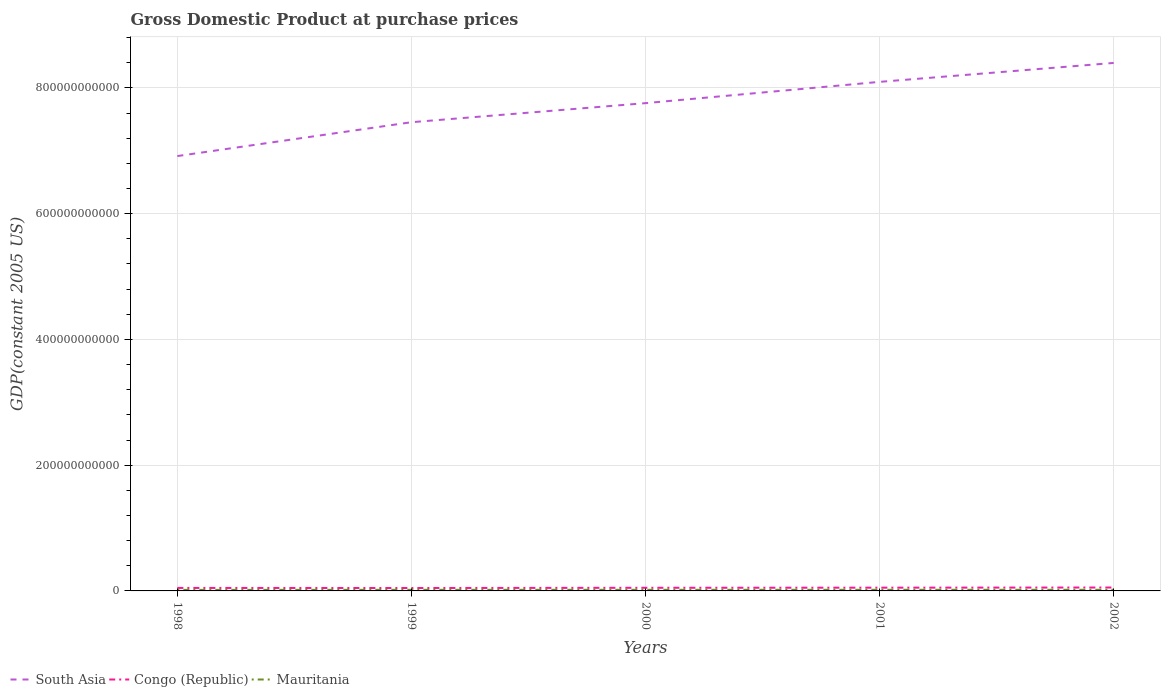Does the line corresponding to Congo (Republic) intersect with the line corresponding to South Asia?
Provide a short and direct response. No. Is the number of lines equal to the number of legend labels?
Your response must be concise. Yes. Across all years, what is the maximum GDP at purchase prices in Mauritania?
Offer a terse response. 1.62e+09. In which year was the GDP at purchase prices in Mauritania maximum?
Your response must be concise. 1998. What is the total GDP at purchase prices in Congo (Republic) in the graph?
Keep it short and to the point. -3.51e+08. What is the difference between the highest and the second highest GDP at purchase prices in Congo (Republic)?
Give a very brief answer. 7.78e+08. What is the difference between two consecutive major ticks on the Y-axis?
Make the answer very short. 2.00e+11. Are the values on the major ticks of Y-axis written in scientific E-notation?
Make the answer very short. No. What is the title of the graph?
Offer a very short reply. Gross Domestic Product at purchase prices. What is the label or title of the X-axis?
Ensure brevity in your answer.  Years. What is the label or title of the Y-axis?
Your answer should be compact. GDP(constant 2005 US). What is the GDP(constant 2005 US) in South Asia in 1998?
Offer a very short reply. 6.92e+11. What is the GDP(constant 2005 US) of Congo (Republic) in 1998?
Give a very brief answer. 4.76e+09. What is the GDP(constant 2005 US) in Mauritania in 1998?
Offer a very short reply. 1.62e+09. What is the GDP(constant 2005 US) of South Asia in 1999?
Offer a terse response. 7.46e+11. What is the GDP(constant 2005 US) of Congo (Republic) in 1999?
Provide a succinct answer. 4.64e+09. What is the GDP(constant 2005 US) in Mauritania in 1999?
Make the answer very short. 1.75e+09. What is the GDP(constant 2005 US) of South Asia in 2000?
Offer a terse response. 7.76e+11. What is the GDP(constant 2005 US) in Congo (Republic) in 2000?
Keep it short and to the point. 4.99e+09. What is the GDP(constant 2005 US) in Mauritania in 2000?
Ensure brevity in your answer.  1.74e+09. What is the GDP(constant 2005 US) of South Asia in 2001?
Your answer should be very brief. 8.10e+11. What is the GDP(constant 2005 US) of Congo (Republic) in 2001?
Ensure brevity in your answer.  5.18e+09. What is the GDP(constant 2005 US) in Mauritania in 2001?
Offer a terse response. 1.78e+09. What is the GDP(constant 2005 US) in South Asia in 2002?
Provide a succinct answer. 8.40e+11. What is the GDP(constant 2005 US) of Congo (Republic) in 2002?
Give a very brief answer. 5.42e+09. What is the GDP(constant 2005 US) in Mauritania in 2002?
Your answer should be very brief. 1.79e+09. Across all years, what is the maximum GDP(constant 2005 US) in South Asia?
Your response must be concise. 8.40e+11. Across all years, what is the maximum GDP(constant 2005 US) in Congo (Republic)?
Provide a succinct answer. 5.42e+09. Across all years, what is the maximum GDP(constant 2005 US) of Mauritania?
Your answer should be compact. 1.79e+09. Across all years, what is the minimum GDP(constant 2005 US) in South Asia?
Provide a short and direct response. 6.92e+11. Across all years, what is the minimum GDP(constant 2005 US) in Congo (Republic)?
Make the answer very short. 4.64e+09. Across all years, what is the minimum GDP(constant 2005 US) in Mauritania?
Make the answer very short. 1.62e+09. What is the total GDP(constant 2005 US) in South Asia in the graph?
Provide a succinct answer. 3.86e+12. What is the total GDP(constant 2005 US) of Congo (Republic) in the graph?
Ensure brevity in your answer.  2.50e+1. What is the total GDP(constant 2005 US) in Mauritania in the graph?
Offer a terse response. 8.68e+09. What is the difference between the GDP(constant 2005 US) in South Asia in 1998 and that in 1999?
Make the answer very short. -5.39e+1. What is the difference between the GDP(constant 2005 US) of Congo (Republic) in 1998 and that in 1999?
Provide a short and direct response. 1.23e+08. What is the difference between the GDP(constant 2005 US) in Mauritania in 1998 and that in 1999?
Give a very brief answer. -1.25e+08. What is the difference between the GDP(constant 2005 US) in South Asia in 1998 and that in 2000?
Provide a succinct answer. -8.42e+1. What is the difference between the GDP(constant 2005 US) in Congo (Republic) in 1998 and that in 2000?
Your answer should be compact. -2.28e+08. What is the difference between the GDP(constant 2005 US) of Mauritania in 1998 and that in 2000?
Offer a terse response. -1.18e+08. What is the difference between the GDP(constant 2005 US) in South Asia in 1998 and that in 2001?
Your response must be concise. -1.18e+11. What is the difference between the GDP(constant 2005 US) in Congo (Republic) in 1998 and that in 2001?
Ensure brevity in your answer.  -4.18e+08. What is the difference between the GDP(constant 2005 US) in Mauritania in 1998 and that in 2001?
Provide a short and direct response. -1.53e+08. What is the difference between the GDP(constant 2005 US) of South Asia in 1998 and that in 2002?
Provide a succinct answer. -1.48e+11. What is the difference between the GDP(constant 2005 US) in Congo (Republic) in 1998 and that in 2002?
Your answer should be very brief. -6.55e+08. What is the difference between the GDP(constant 2005 US) of Mauritania in 1998 and that in 2002?
Make the answer very short. -1.65e+08. What is the difference between the GDP(constant 2005 US) of South Asia in 1999 and that in 2000?
Provide a succinct answer. -3.03e+1. What is the difference between the GDP(constant 2005 US) of Congo (Republic) in 1999 and that in 2000?
Offer a very short reply. -3.51e+08. What is the difference between the GDP(constant 2005 US) in Mauritania in 1999 and that in 2000?
Offer a very short reply. 7.53e+06. What is the difference between the GDP(constant 2005 US) of South Asia in 1999 and that in 2001?
Your answer should be very brief. -6.42e+1. What is the difference between the GDP(constant 2005 US) in Congo (Republic) in 1999 and that in 2001?
Keep it short and to the point. -5.41e+08. What is the difference between the GDP(constant 2005 US) in Mauritania in 1999 and that in 2001?
Provide a succinct answer. -2.75e+07. What is the difference between the GDP(constant 2005 US) in South Asia in 1999 and that in 2002?
Your response must be concise. -9.43e+1. What is the difference between the GDP(constant 2005 US) of Congo (Republic) in 1999 and that in 2002?
Provide a succinct answer. -7.78e+08. What is the difference between the GDP(constant 2005 US) in Mauritania in 1999 and that in 2002?
Offer a very short reply. -3.93e+07. What is the difference between the GDP(constant 2005 US) in South Asia in 2000 and that in 2001?
Offer a terse response. -3.38e+1. What is the difference between the GDP(constant 2005 US) in Congo (Republic) in 2000 and that in 2001?
Ensure brevity in your answer.  -1.90e+08. What is the difference between the GDP(constant 2005 US) of Mauritania in 2000 and that in 2001?
Your response must be concise. -3.50e+07. What is the difference between the GDP(constant 2005 US) in South Asia in 2000 and that in 2002?
Make the answer very short. -6.40e+1. What is the difference between the GDP(constant 2005 US) of Congo (Republic) in 2000 and that in 2002?
Make the answer very short. -4.27e+08. What is the difference between the GDP(constant 2005 US) of Mauritania in 2000 and that in 2002?
Give a very brief answer. -4.68e+07. What is the difference between the GDP(constant 2005 US) of South Asia in 2001 and that in 2002?
Your response must be concise. -3.01e+1. What is the difference between the GDP(constant 2005 US) of Congo (Republic) in 2001 and that in 2002?
Provide a short and direct response. -2.37e+08. What is the difference between the GDP(constant 2005 US) of Mauritania in 2001 and that in 2002?
Ensure brevity in your answer.  -1.18e+07. What is the difference between the GDP(constant 2005 US) in South Asia in 1998 and the GDP(constant 2005 US) in Congo (Republic) in 1999?
Your answer should be compact. 6.87e+11. What is the difference between the GDP(constant 2005 US) of South Asia in 1998 and the GDP(constant 2005 US) of Mauritania in 1999?
Your response must be concise. 6.90e+11. What is the difference between the GDP(constant 2005 US) in Congo (Republic) in 1998 and the GDP(constant 2005 US) in Mauritania in 1999?
Your answer should be very brief. 3.01e+09. What is the difference between the GDP(constant 2005 US) of South Asia in 1998 and the GDP(constant 2005 US) of Congo (Republic) in 2000?
Your answer should be compact. 6.87e+11. What is the difference between the GDP(constant 2005 US) of South Asia in 1998 and the GDP(constant 2005 US) of Mauritania in 2000?
Keep it short and to the point. 6.90e+11. What is the difference between the GDP(constant 2005 US) of Congo (Republic) in 1998 and the GDP(constant 2005 US) of Mauritania in 2000?
Provide a short and direct response. 3.02e+09. What is the difference between the GDP(constant 2005 US) of South Asia in 1998 and the GDP(constant 2005 US) of Congo (Republic) in 2001?
Ensure brevity in your answer.  6.86e+11. What is the difference between the GDP(constant 2005 US) in South Asia in 1998 and the GDP(constant 2005 US) in Mauritania in 2001?
Make the answer very short. 6.90e+11. What is the difference between the GDP(constant 2005 US) of Congo (Republic) in 1998 and the GDP(constant 2005 US) of Mauritania in 2001?
Give a very brief answer. 2.98e+09. What is the difference between the GDP(constant 2005 US) of South Asia in 1998 and the GDP(constant 2005 US) of Congo (Republic) in 2002?
Keep it short and to the point. 6.86e+11. What is the difference between the GDP(constant 2005 US) of South Asia in 1998 and the GDP(constant 2005 US) of Mauritania in 2002?
Keep it short and to the point. 6.90e+11. What is the difference between the GDP(constant 2005 US) of Congo (Republic) in 1998 and the GDP(constant 2005 US) of Mauritania in 2002?
Your answer should be compact. 2.97e+09. What is the difference between the GDP(constant 2005 US) in South Asia in 1999 and the GDP(constant 2005 US) in Congo (Republic) in 2000?
Give a very brief answer. 7.41e+11. What is the difference between the GDP(constant 2005 US) of South Asia in 1999 and the GDP(constant 2005 US) of Mauritania in 2000?
Your answer should be very brief. 7.44e+11. What is the difference between the GDP(constant 2005 US) of Congo (Republic) in 1999 and the GDP(constant 2005 US) of Mauritania in 2000?
Provide a succinct answer. 2.89e+09. What is the difference between the GDP(constant 2005 US) in South Asia in 1999 and the GDP(constant 2005 US) in Congo (Republic) in 2001?
Keep it short and to the point. 7.40e+11. What is the difference between the GDP(constant 2005 US) of South Asia in 1999 and the GDP(constant 2005 US) of Mauritania in 2001?
Make the answer very short. 7.44e+11. What is the difference between the GDP(constant 2005 US) in Congo (Republic) in 1999 and the GDP(constant 2005 US) in Mauritania in 2001?
Your answer should be compact. 2.86e+09. What is the difference between the GDP(constant 2005 US) in South Asia in 1999 and the GDP(constant 2005 US) in Congo (Republic) in 2002?
Your answer should be compact. 7.40e+11. What is the difference between the GDP(constant 2005 US) in South Asia in 1999 and the GDP(constant 2005 US) in Mauritania in 2002?
Your answer should be very brief. 7.44e+11. What is the difference between the GDP(constant 2005 US) of Congo (Republic) in 1999 and the GDP(constant 2005 US) of Mauritania in 2002?
Your response must be concise. 2.85e+09. What is the difference between the GDP(constant 2005 US) in South Asia in 2000 and the GDP(constant 2005 US) in Congo (Republic) in 2001?
Give a very brief answer. 7.71e+11. What is the difference between the GDP(constant 2005 US) in South Asia in 2000 and the GDP(constant 2005 US) in Mauritania in 2001?
Give a very brief answer. 7.74e+11. What is the difference between the GDP(constant 2005 US) of Congo (Republic) in 2000 and the GDP(constant 2005 US) of Mauritania in 2001?
Your answer should be compact. 3.21e+09. What is the difference between the GDP(constant 2005 US) in South Asia in 2000 and the GDP(constant 2005 US) in Congo (Republic) in 2002?
Ensure brevity in your answer.  7.70e+11. What is the difference between the GDP(constant 2005 US) of South Asia in 2000 and the GDP(constant 2005 US) of Mauritania in 2002?
Keep it short and to the point. 7.74e+11. What is the difference between the GDP(constant 2005 US) in Congo (Republic) in 2000 and the GDP(constant 2005 US) in Mauritania in 2002?
Give a very brief answer. 3.20e+09. What is the difference between the GDP(constant 2005 US) of South Asia in 2001 and the GDP(constant 2005 US) of Congo (Republic) in 2002?
Keep it short and to the point. 8.04e+11. What is the difference between the GDP(constant 2005 US) of South Asia in 2001 and the GDP(constant 2005 US) of Mauritania in 2002?
Provide a succinct answer. 8.08e+11. What is the difference between the GDP(constant 2005 US) in Congo (Republic) in 2001 and the GDP(constant 2005 US) in Mauritania in 2002?
Make the answer very short. 3.39e+09. What is the average GDP(constant 2005 US) of South Asia per year?
Offer a terse response. 7.72e+11. What is the average GDP(constant 2005 US) in Congo (Republic) per year?
Provide a succinct answer. 5.00e+09. What is the average GDP(constant 2005 US) of Mauritania per year?
Keep it short and to the point. 1.74e+09. In the year 1998, what is the difference between the GDP(constant 2005 US) of South Asia and GDP(constant 2005 US) of Congo (Republic)?
Give a very brief answer. 6.87e+11. In the year 1998, what is the difference between the GDP(constant 2005 US) of South Asia and GDP(constant 2005 US) of Mauritania?
Provide a short and direct response. 6.90e+11. In the year 1998, what is the difference between the GDP(constant 2005 US) of Congo (Republic) and GDP(constant 2005 US) of Mauritania?
Make the answer very short. 3.14e+09. In the year 1999, what is the difference between the GDP(constant 2005 US) in South Asia and GDP(constant 2005 US) in Congo (Republic)?
Offer a terse response. 7.41e+11. In the year 1999, what is the difference between the GDP(constant 2005 US) in South Asia and GDP(constant 2005 US) in Mauritania?
Offer a terse response. 7.44e+11. In the year 1999, what is the difference between the GDP(constant 2005 US) of Congo (Republic) and GDP(constant 2005 US) of Mauritania?
Offer a very short reply. 2.89e+09. In the year 2000, what is the difference between the GDP(constant 2005 US) in South Asia and GDP(constant 2005 US) in Congo (Republic)?
Your response must be concise. 7.71e+11. In the year 2000, what is the difference between the GDP(constant 2005 US) in South Asia and GDP(constant 2005 US) in Mauritania?
Make the answer very short. 7.74e+11. In the year 2000, what is the difference between the GDP(constant 2005 US) of Congo (Republic) and GDP(constant 2005 US) of Mauritania?
Provide a short and direct response. 3.25e+09. In the year 2001, what is the difference between the GDP(constant 2005 US) in South Asia and GDP(constant 2005 US) in Congo (Republic)?
Provide a succinct answer. 8.04e+11. In the year 2001, what is the difference between the GDP(constant 2005 US) in South Asia and GDP(constant 2005 US) in Mauritania?
Provide a short and direct response. 8.08e+11. In the year 2001, what is the difference between the GDP(constant 2005 US) of Congo (Republic) and GDP(constant 2005 US) of Mauritania?
Ensure brevity in your answer.  3.40e+09. In the year 2002, what is the difference between the GDP(constant 2005 US) in South Asia and GDP(constant 2005 US) in Congo (Republic)?
Ensure brevity in your answer.  8.34e+11. In the year 2002, what is the difference between the GDP(constant 2005 US) in South Asia and GDP(constant 2005 US) in Mauritania?
Offer a terse response. 8.38e+11. In the year 2002, what is the difference between the GDP(constant 2005 US) in Congo (Republic) and GDP(constant 2005 US) in Mauritania?
Ensure brevity in your answer.  3.63e+09. What is the ratio of the GDP(constant 2005 US) of South Asia in 1998 to that in 1999?
Give a very brief answer. 0.93. What is the ratio of the GDP(constant 2005 US) of Congo (Republic) in 1998 to that in 1999?
Give a very brief answer. 1.03. What is the ratio of the GDP(constant 2005 US) of Mauritania in 1998 to that in 1999?
Your answer should be very brief. 0.93. What is the ratio of the GDP(constant 2005 US) in South Asia in 1998 to that in 2000?
Ensure brevity in your answer.  0.89. What is the ratio of the GDP(constant 2005 US) in Congo (Republic) in 1998 to that in 2000?
Provide a short and direct response. 0.95. What is the ratio of the GDP(constant 2005 US) of Mauritania in 1998 to that in 2000?
Make the answer very short. 0.93. What is the ratio of the GDP(constant 2005 US) in South Asia in 1998 to that in 2001?
Provide a short and direct response. 0.85. What is the ratio of the GDP(constant 2005 US) in Congo (Republic) in 1998 to that in 2001?
Provide a succinct answer. 0.92. What is the ratio of the GDP(constant 2005 US) in Mauritania in 1998 to that in 2001?
Your response must be concise. 0.91. What is the ratio of the GDP(constant 2005 US) of South Asia in 1998 to that in 2002?
Your answer should be compact. 0.82. What is the ratio of the GDP(constant 2005 US) of Congo (Republic) in 1998 to that in 2002?
Offer a terse response. 0.88. What is the ratio of the GDP(constant 2005 US) of Mauritania in 1998 to that in 2002?
Give a very brief answer. 0.91. What is the ratio of the GDP(constant 2005 US) of South Asia in 1999 to that in 2000?
Provide a succinct answer. 0.96. What is the ratio of the GDP(constant 2005 US) in Congo (Republic) in 1999 to that in 2000?
Keep it short and to the point. 0.93. What is the ratio of the GDP(constant 2005 US) of Mauritania in 1999 to that in 2000?
Keep it short and to the point. 1. What is the ratio of the GDP(constant 2005 US) of South Asia in 1999 to that in 2001?
Offer a terse response. 0.92. What is the ratio of the GDP(constant 2005 US) in Congo (Republic) in 1999 to that in 2001?
Provide a succinct answer. 0.9. What is the ratio of the GDP(constant 2005 US) of Mauritania in 1999 to that in 2001?
Keep it short and to the point. 0.98. What is the ratio of the GDP(constant 2005 US) in South Asia in 1999 to that in 2002?
Your response must be concise. 0.89. What is the ratio of the GDP(constant 2005 US) of Congo (Republic) in 1999 to that in 2002?
Offer a very short reply. 0.86. What is the ratio of the GDP(constant 2005 US) of Mauritania in 1999 to that in 2002?
Your response must be concise. 0.98. What is the ratio of the GDP(constant 2005 US) of South Asia in 2000 to that in 2001?
Provide a short and direct response. 0.96. What is the ratio of the GDP(constant 2005 US) in Congo (Republic) in 2000 to that in 2001?
Provide a short and direct response. 0.96. What is the ratio of the GDP(constant 2005 US) of Mauritania in 2000 to that in 2001?
Provide a short and direct response. 0.98. What is the ratio of the GDP(constant 2005 US) of South Asia in 2000 to that in 2002?
Keep it short and to the point. 0.92. What is the ratio of the GDP(constant 2005 US) of Congo (Republic) in 2000 to that in 2002?
Offer a terse response. 0.92. What is the ratio of the GDP(constant 2005 US) of Mauritania in 2000 to that in 2002?
Make the answer very short. 0.97. What is the ratio of the GDP(constant 2005 US) of South Asia in 2001 to that in 2002?
Keep it short and to the point. 0.96. What is the ratio of the GDP(constant 2005 US) of Congo (Republic) in 2001 to that in 2002?
Your answer should be compact. 0.96. What is the ratio of the GDP(constant 2005 US) in Mauritania in 2001 to that in 2002?
Offer a very short reply. 0.99. What is the difference between the highest and the second highest GDP(constant 2005 US) in South Asia?
Your response must be concise. 3.01e+1. What is the difference between the highest and the second highest GDP(constant 2005 US) of Congo (Republic)?
Ensure brevity in your answer.  2.37e+08. What is the difference between the highest and the second highest GDP(constant 2005 US) of Mauritania?
Your response must be concise. 1.18e+07. What is the difference between the highest and the lowest GDP(constant 2005 US) of South Asia?
Provide a succinct answer. 1.48e+11. What is the difference between the highest and the lowest GDP(constant 2005 US) in Congo (Republic)?
Give a very brief answer. 7.78e+08. What is the difference between the highest and the lowest GDP(constant 2005 US) of Mauritania?
Ensure brevity in your answer.  1.65e+08. 